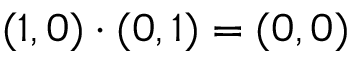Convert formula to latex. <formula><loc_0><loc_0><loc_500><loc_500>( 1 , 0 ) \cdot ( 0 , 1 ) = ( 0 , 0 )</formula> 